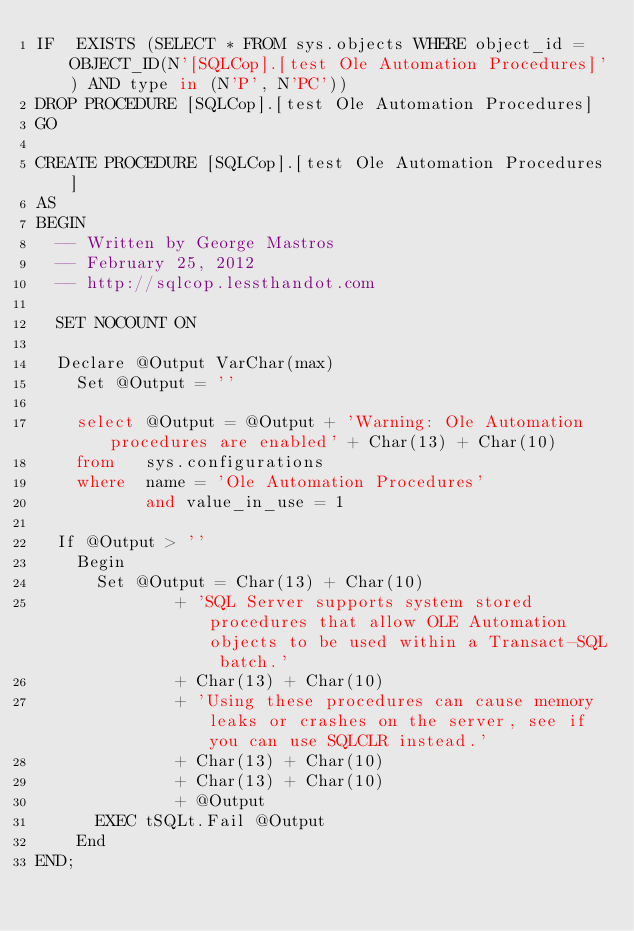Convert code to text. <code><loc_0><loc_0><loc_500><loc_500><_SQL_>IF  EXISTS (SELECT * FROM sys.objects WHERE object_id = OBJECT_ID(N'[SQLCop].[test Ole Automation Procedures]') AND type in (N'P', N'PC'))
DROP PROCEDURE [SQLCop].[test Ole Automation Procedures]
GO

CREATE PROCEDURE [SQLCop].[test Ole Automation Procedures]
AS
BEGIN
	-- Written by George Mastros
	-- February 25, 2012
	-- http://sqlcop.lessthandot.com
	
	SET NOCOUNT ON
	
	Declare @Output VarChar(max)
    Set @Output = ''

    select @Output = @Output + 'Warning: Ole Automation procedures are enabled' + Char(13) + Char(10)
    from   sys.configurations
    where  name = 'Ole Automation Procedures'
           and value_in_use = 1
                   
	If @Output > '' 
		Begin
			Set @Output = Char(13) + Char(10) 
						  + 'SQL Server supports system stored procedures that allow OLE Automation objects to be used within a Transact-SQL batch.'
						  + Char(13) + Char(10) 
						  + 'Using these procedures can cause memory leaks or crashes on the server, see if you can use SQLCLR instead.'
						  + Char(13) + Char(10) 
						  + Char(13) + Char(10) 
						  + @Output
			EXEC tSQLt.Fail @Output
		End  
END;</code> 